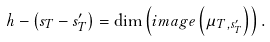Convert formula to latex. <formula><loc_0><loc_0><loc_500><loc_500>h - \left ( s _ { T } - s _ { T } ^ { \prime } \right ) = \dim \left ( i m a g e \left ( \mu _ { T , s _ { T } ^ { \prime } } \right ) \right ) .</formula> 